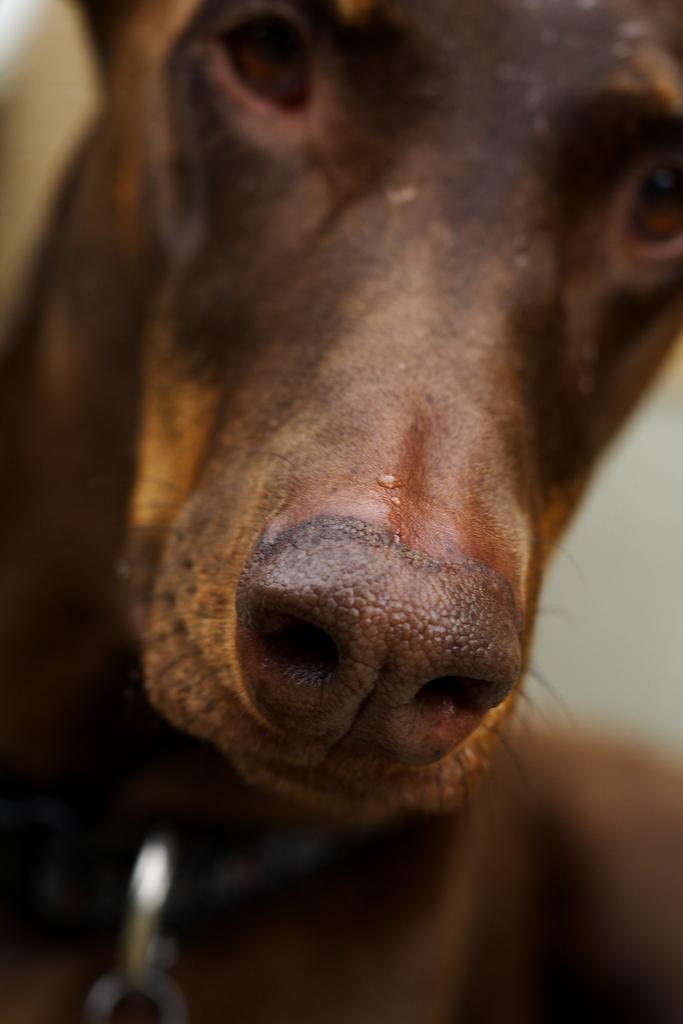What type of animal is present in the image? There is a dog in the image. What color is the dog in the image? The dog is brown in color. What type of industry is depicted in the image? There is no industry present in the image; it features a brown dog. What type of cloth is being used to cover the dog in the image? There is no cloth present in the image; the dog is not covered. 